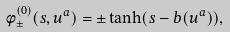<formula> <loc_0><loc_0><loc_500><loc_500>\phi ^ { ( 0 ) } _ { \pm } ( s , u ^ { a } ) = \pm \tanh ( s - b ( u ^ { a } ) ) ,</formula> 